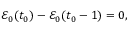<formula> <loc_0><loc_0><loc_500><loc_500>\begin{array} { r } { \mathcal { E } _ { 0 } ( t _ { 0 } ) - \mathcal { E } _ { 0 } ( t _ { 0 } - 1 ) = 0 , } \end{array}</formula> 